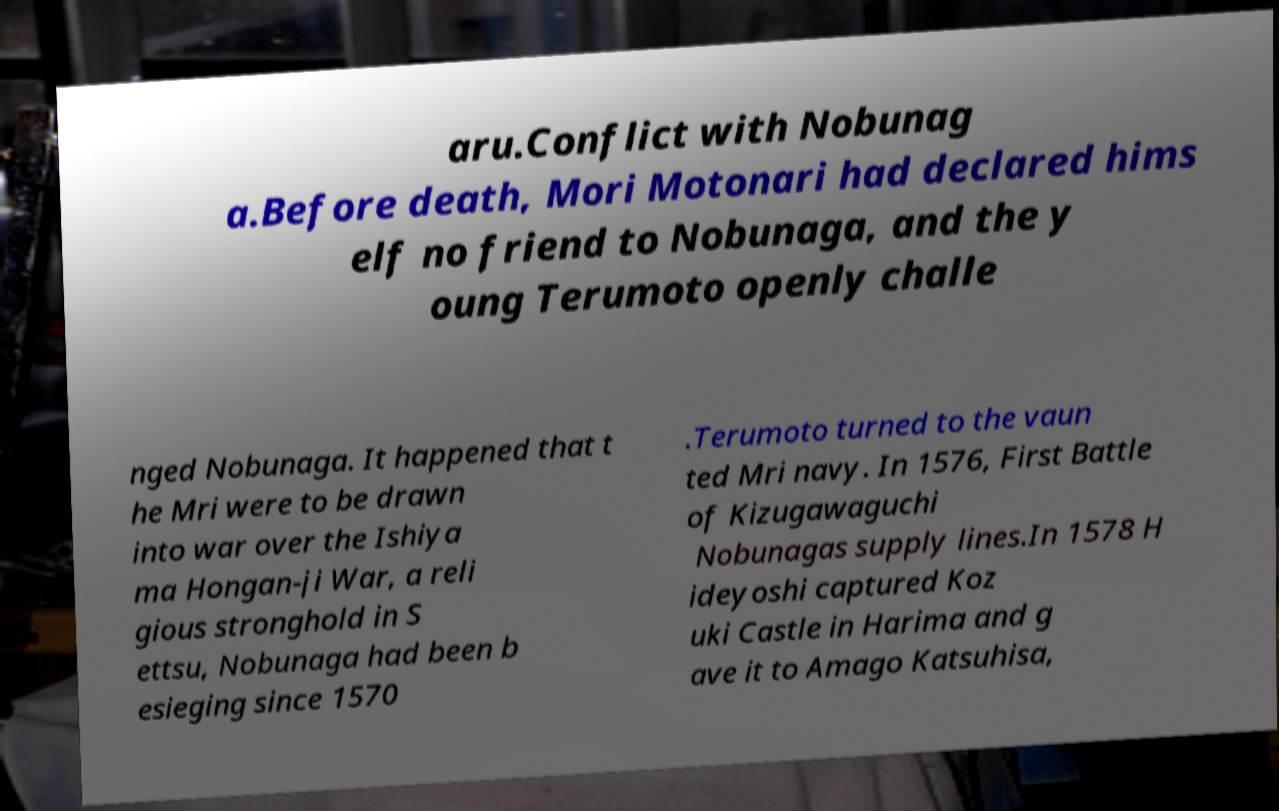Could you extract and type out the text from this image? aru.Conflict with Nobunag a.Before death, Mori Motonari had declared hims elf no friend to Nobunaga, and the y oung Terumoto openly challe nged Nobunaga. It happened that t he Mri were to be drawn into war over the Ishiya ma Hongan-ji War, a reli gious stronghold in S ettsu, Nobunaga had been b esieging since 1570 .Terumoto turned to the vaun ted Mri navy. In 1576, First Battle of Kizugawaguchi Nobunagas supply lines.In 1578 H ideyoshi captured Koz uki Castle in Harima and g ave it to Amago Katsuhisa, 